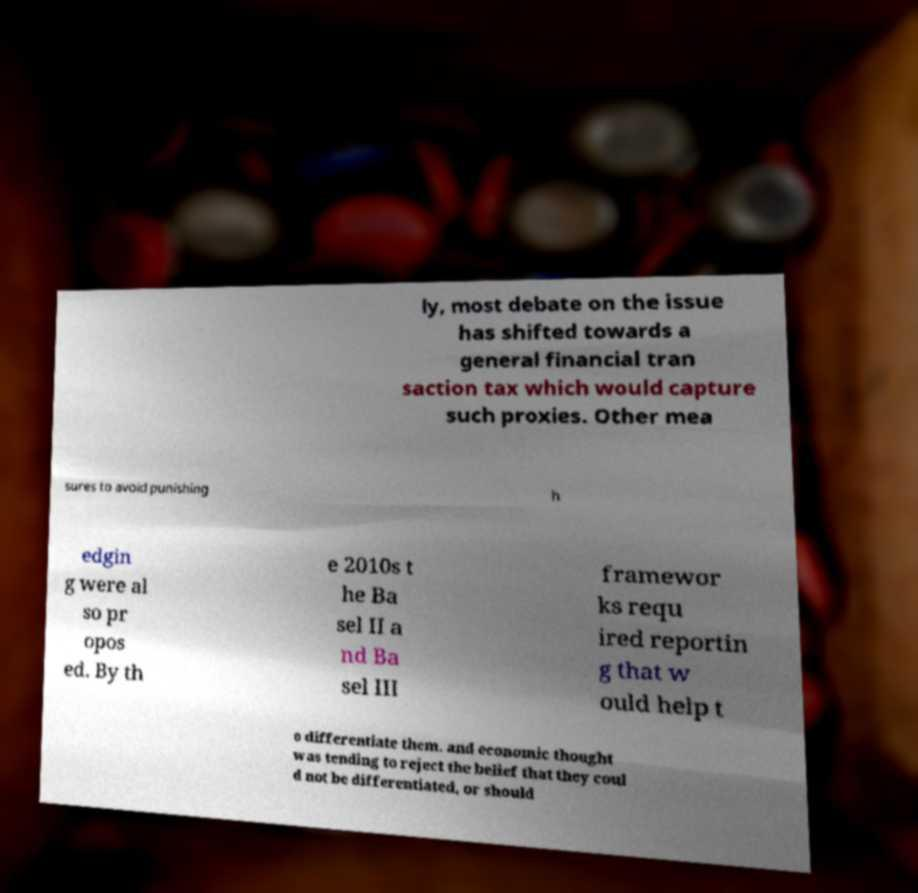Could you extract and type out the text from this image? ly, most debate on the issue has shifted towards a general financial tran saction tax which would capture such proxies. Other mea sures to avoid punishing h edgin g were al so pr opos ed. By th e 2010s t he Ba sel II a nd Ba sel III framewor ks requ ired reportin g that w ould help t o differentiate them. and economic thought was tending to reject the belief that they coul d not be differentiated, or should 